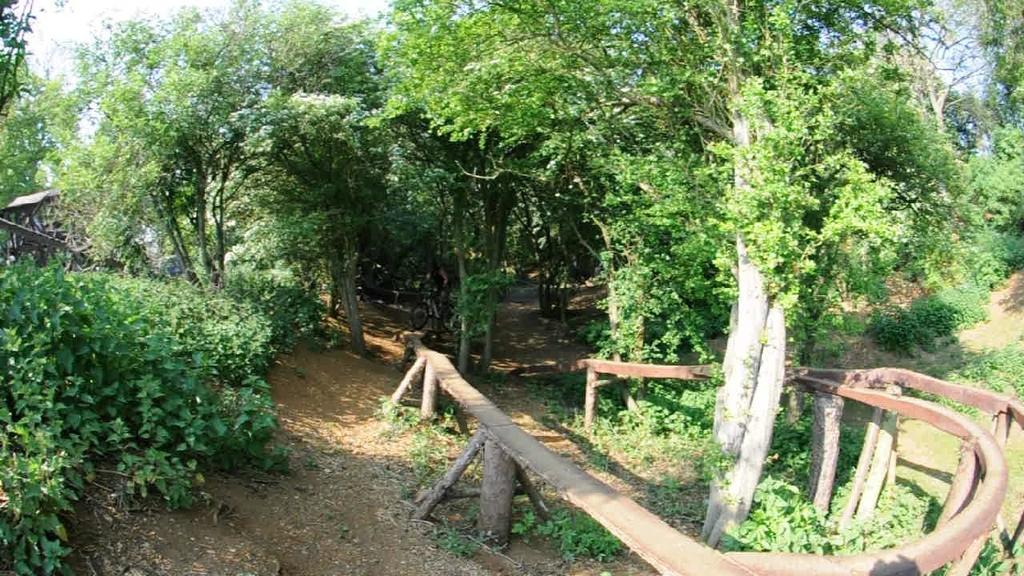What type of fence is visible in the image? There is a wooden fence in the image. What other natural elements can be seen in the image? There are plants and trees visible in the image. What part of the natural environment is visible in the image? The sky is visible in the image. What type of treatment is being administered to the plants in the image? There is no indication in the image that any treatment is being administered to the plants. 